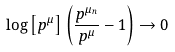<formula> <loc_0><loc_0><loc_500><loc_500>\log \left [ p ^ { \mu } \right ] \left ( \frac { p ^ { \mu _ { n } } } { p ^ { \mu } } - 1 \right ) \rightarrow 0</formula> 